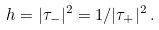Convert formula to latex. <formula><loc_0><loc_0><loc_500><loc_500>h = | \tau _ { - } | ^ { 2 } = 1 / | \tau _ { + } | ^ { 2 } \, .</formula> 